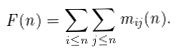<formula> <loc_0><loc_0><loc_500><loc_500>F ( n ) = \sum _ { i \leq n } \sum _ { j \leq n } m _ { i j } ( n ) .</formula> 